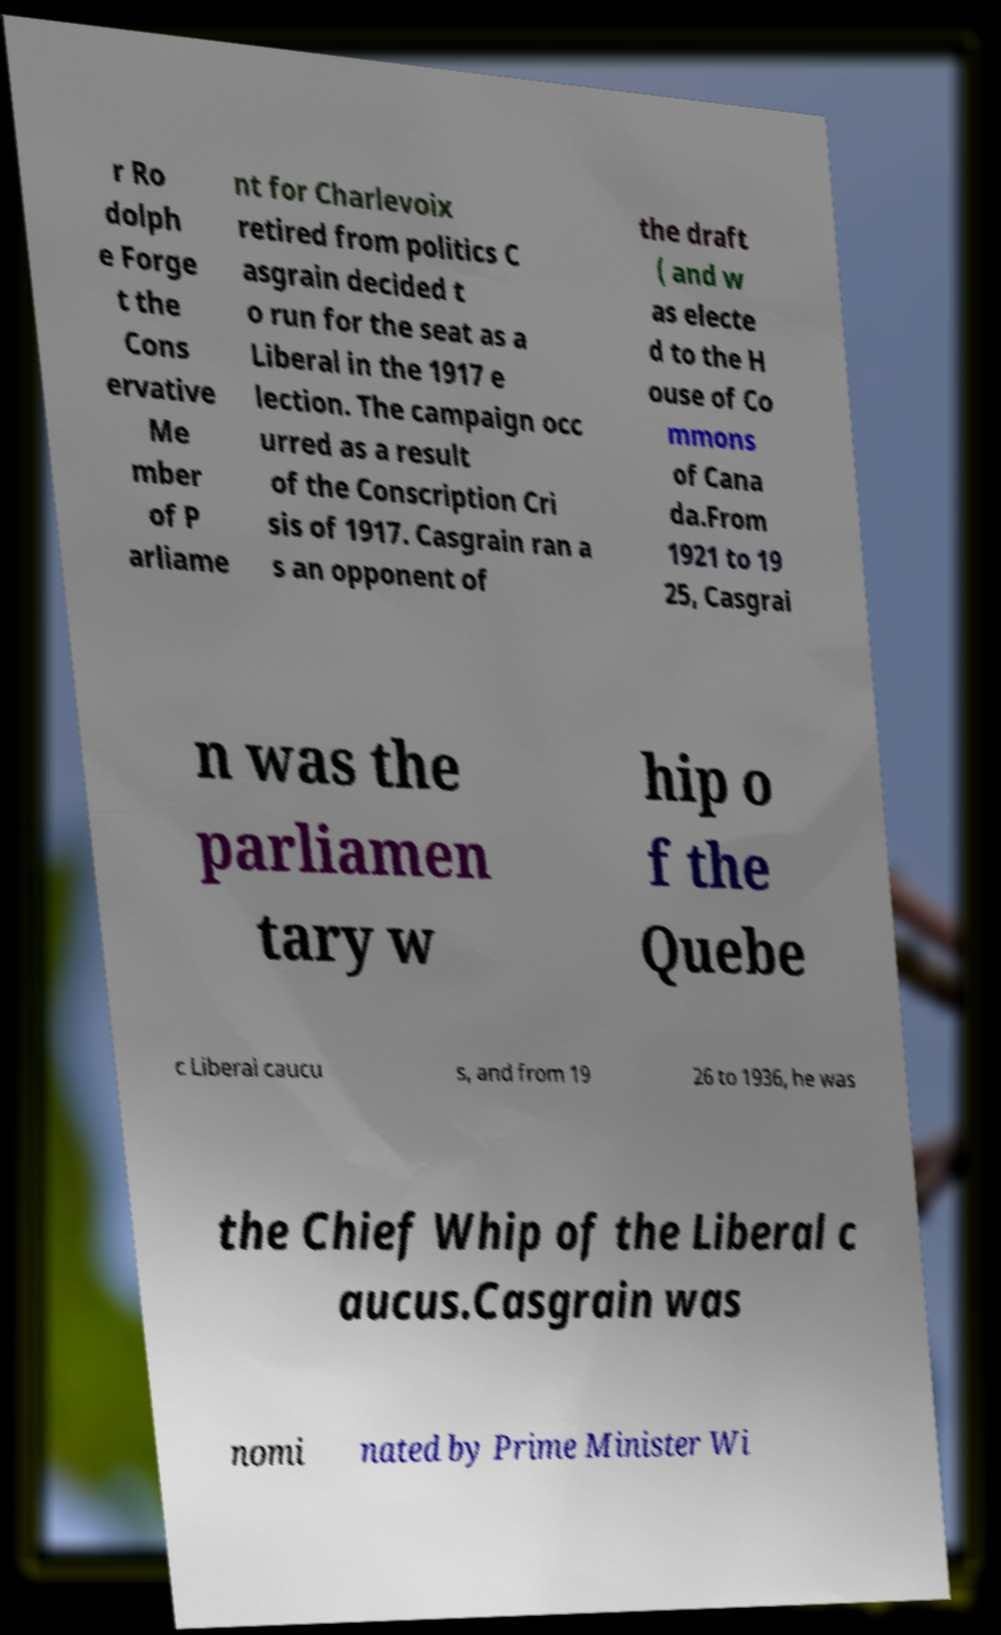There's text embedded in this image that I need extracted. Can you transcribe it verbatim? r Ro dolph e Forge t the Cons ervative Me mber of P arliame nt for Charlevoix retired from politics C asgrain decided t o run for the seat as a Liberal in the 1917 e lection. The campaign occ urred as a result of the Conscription Cri sis of 1917. Casgrain ran a s an opponent of the draft ( and w as electe d to the H ouse of Co mmons of Cana da.From 1921 to 19 25, Casgrai n was the parliamen tary w hip o f the Quebe c Liberal caucu s, and from 19 26 to 1936, he was the Chief Whip of the Liberal c aucus.Casgrain was nomi nated by Prime Minister Wi 